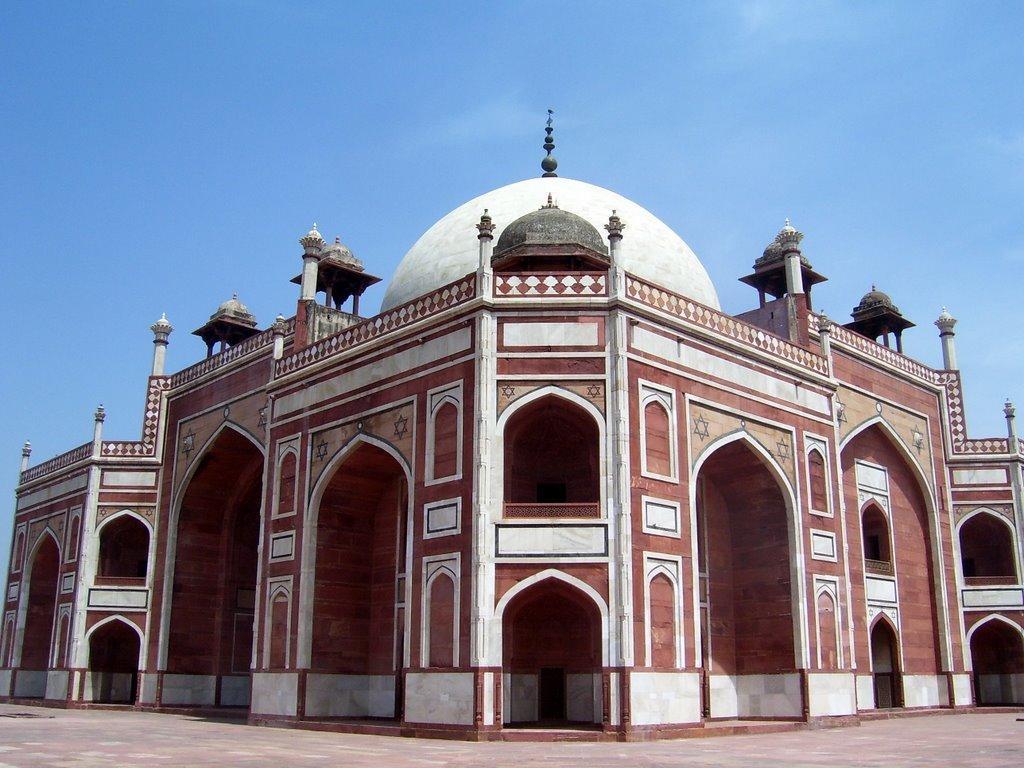Could you give a brief overview of what you see in this image? In this picture there is a brown and white color old mosque with dome. On the top there is a blue sky. 